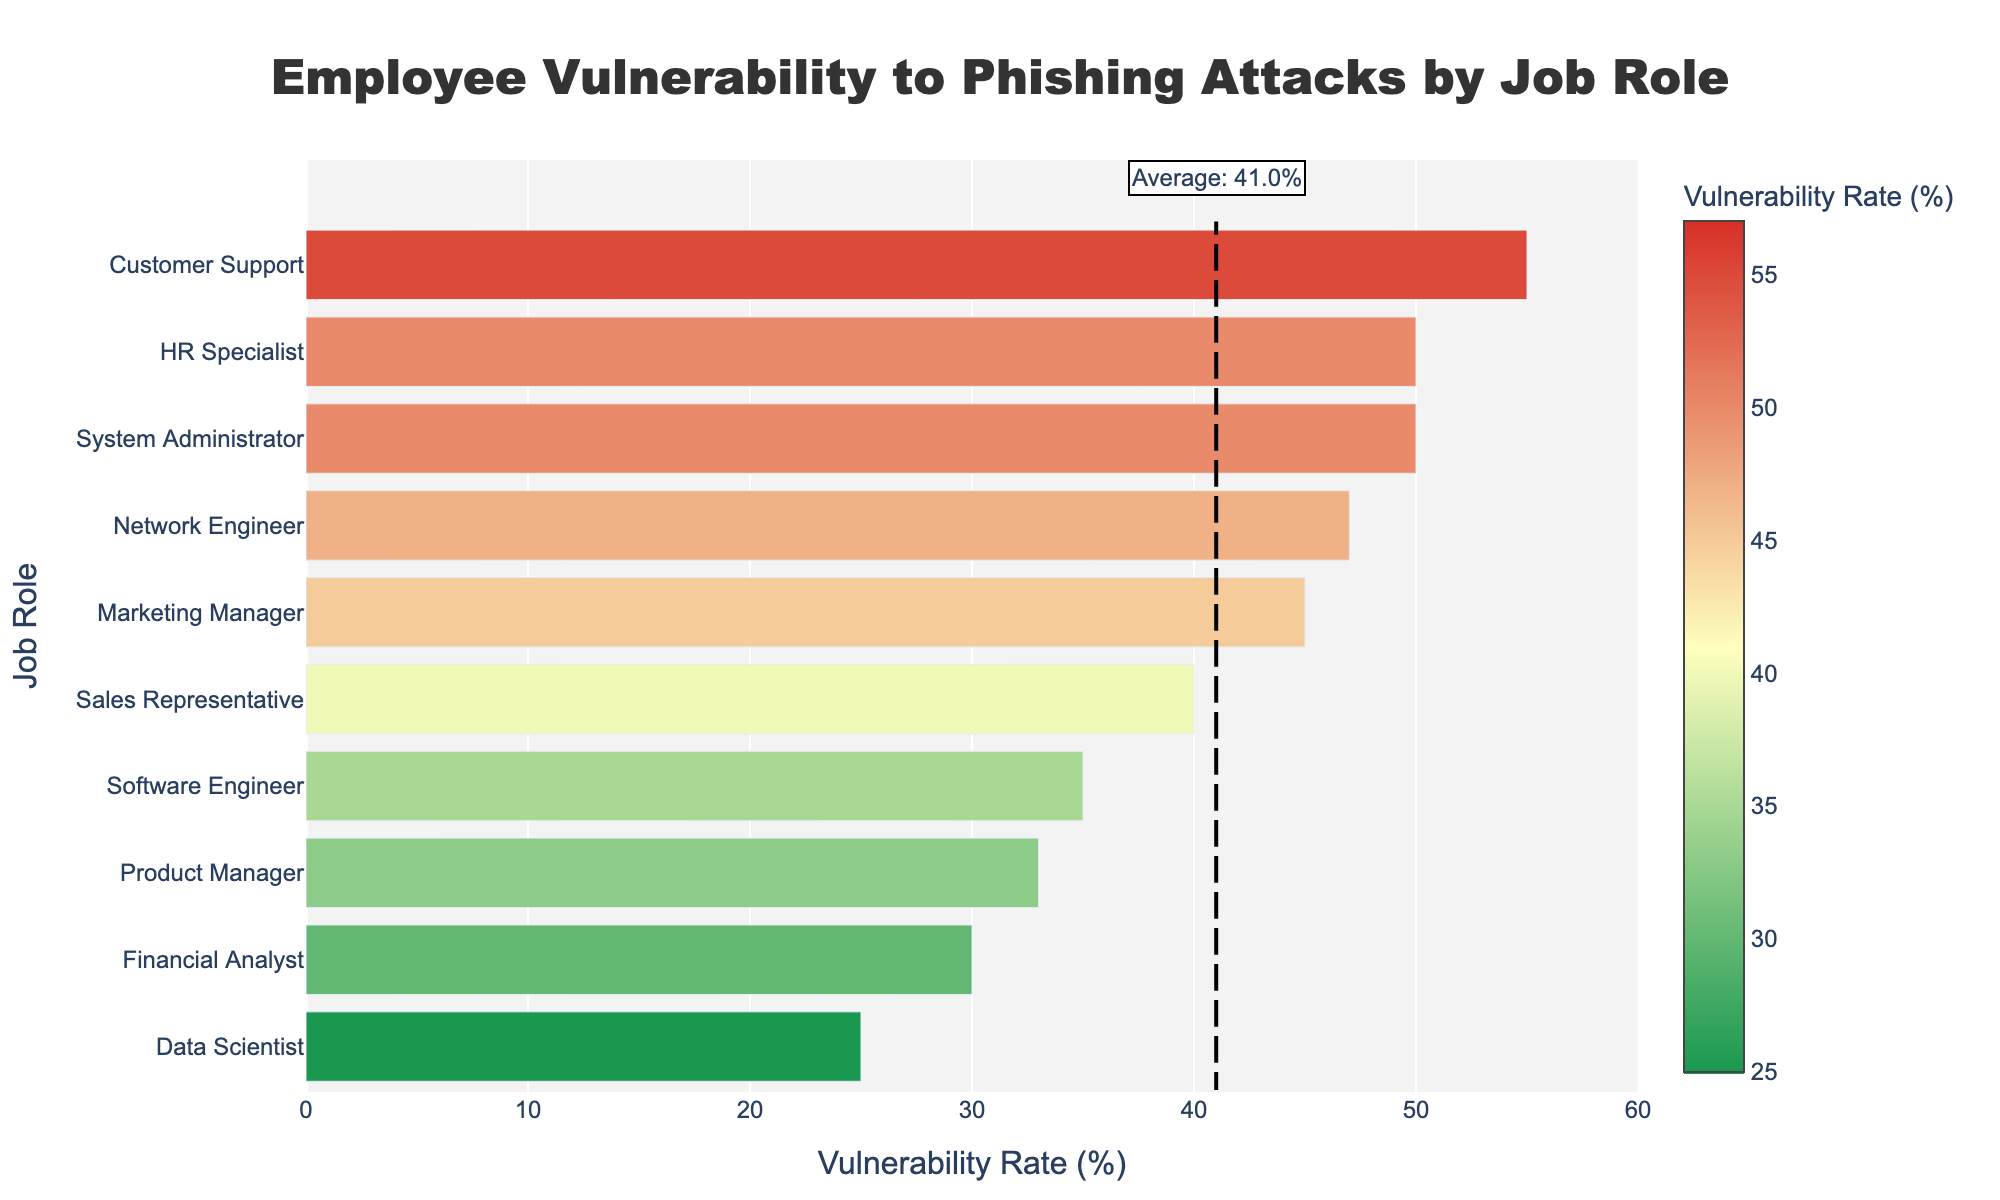Which job role has the highest vulnerability to phishing attacks? The job role with the highest value on the x-axis represents the highest vulnerability. Customer Support has the highest rate at 55%.
Answer: Customer Support Which job role has the lowest vulnerability to phishing attacks? The job role with the lowest value on the x-axis represents the lowest vulnerability. Data Scientist has the lowest rate at 25%.
Answer: Data Scientist Which department has employees with the same vulnerability rate to phishing attacks? Human Resources (HR Specialist) and IT (System Administrator) departments both have roles with a 50% vulnerability rate.
Answer: Human Resources and IT What's the average vulnerability rate to phishing attacks as marked on the chart? The chart includes a dashed line marking the average vulnerability rate, along with an annotation showing "Average: 41.0%".
Answer: 41.0% How do Marketing Managers compare to the average vulnerability rate? Marketing Managers are visualized in green, red, and orange bars while an average line shows 41%. Marketing Managers have a rate of 45%, which is above the average.
Answer: Above average What's the vulnerability rate difference between Software Engineers and Product Managers? Find the values and subtract: Software Engineers have a 35% rate, while Product Managers have a 33% rate. The difference is 35% - 33% = 2%.
Answer: 2% List the job roles with vulnerability rates above the average. Any bars extending to the right of the average line (41%) indicate roles above average: System Administrator (50%), Sales Representative (40%), Marketing Manager (45%), HR Specialist (50%), Customer Support (55%), and Network Engineer (47%).
Answer: System Administrator, Sales Representative, Marketing Manager, HR Specialist, Customer Support, Network Engineer Identify the job role with almost an average vulnerability rate. Analyzing the bars closest to the dashed average line, Product Managers have a rate of 33%, which is just below the average of 41%.
Answer: Product Managers How does the color indicate vulnerability rates? The color transitions from green (low vulnerability), through yellow (mid vulnerability), to red (high vulnerability).
Answer: Green to Red 